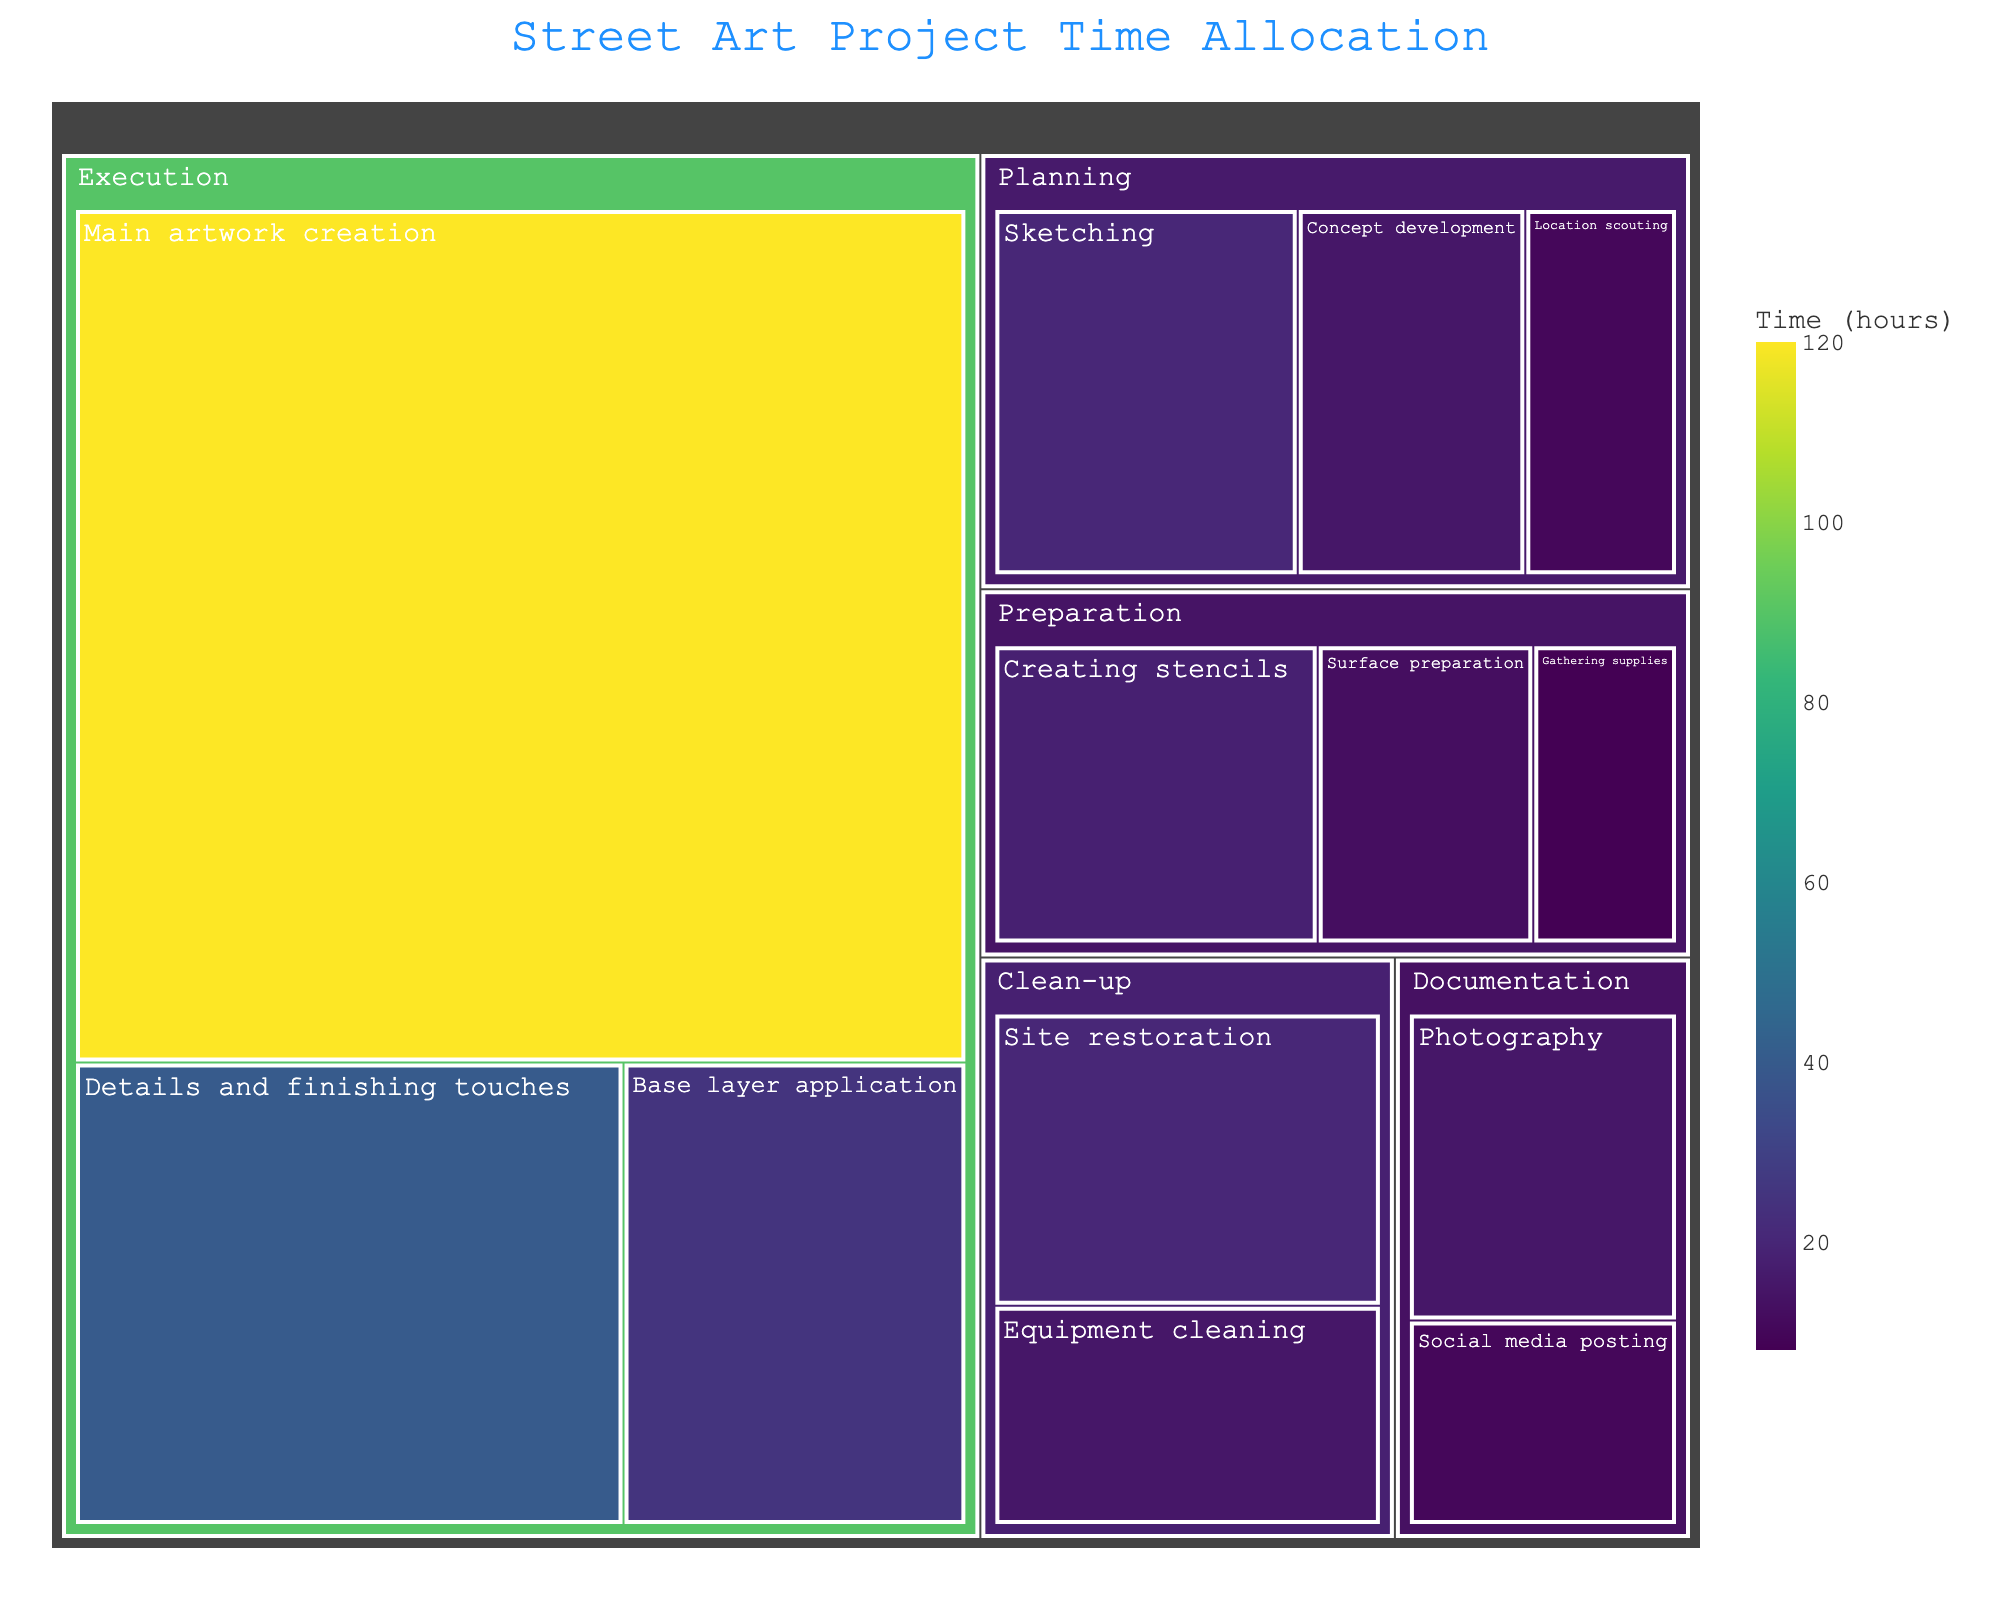Which category takes the most time in the project? Look at the largest section in the treemap. "Execution" has the biggest area, indicating it takes the most time.
Answer: Execution How much total time is spent on the "Planning" category? Sum up the times for "Location scouting" (10), "Concept development" (15), and "Sketching" (20). 10 + 15 + 20 = 45 hours.
Answer: 45 hours Which subcategory within "Preparation" takes the least time? Compare the times for "Gathering supplies" (8), "Surface preparation" (12), and "Creating stencils" (18). "Gathering supplies" is the smallest at 8 hours.
Answer: Gathering supplies How do the times for "Documentation" and "Clean-up" categories compare? Add the times for "Documentation" (15 + 10 = 25) and "Clean-up" (15 + 20 = 35). 25 hours for "Documentation" is less than 35 hours for "Clean-up".
Answer: Clean-up takes more time What's the difference in time between "Base layer application" and "Details and finishing touches"? Subtract the time for "Details and finishing touches" (40) from "Base layer application" (25). 40 - 25 = 15 hours.
Answer: 15 hours Which subcategory in the "Execution" category takes the most time? Within "Execution", the times are "Base layer application" (25), "Main artwork creation" (120), and "Details and finishing touches" (40). "Main artwork creation" takes the most time at 120 hours.
Answer: Main artwork creation What is the average time spent on subcategories within "Planning"? Add the times for "Location scouting" (10), "Concept development" (15), and "Sketching" (20), then divide by the number of subcategories (3). (10 + 15 + 20) / 3 = 45 / 3 = 15 hours.
Answer: 15 hours How does the time for "Sketching" compare to the total time for "Documentation"? "Sketching" takes 20 hours and "Documentation" (Photography + Social media posting) takes 25 hours. 20 hours for "Sketching" is less than 25 hours for "Documentation".
Answer: Documentation takes more time What is the total time spent on all categories combined? Sum the times for all subcategories: 10 + 15 + 20 + 8 + 12 + 18 + 25 + 120 + 40 + 15 + 10 + 15 + 20. Total = 328 hours.
Answer: 328 hours Which single subcategory takes the least time out of all listed? Look at the smallest area in the treemap. "Gathering supplies" takes 8 hours, the least time.
Answer: Gathering supplies 